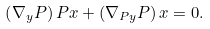Convert formula to latex. <formula><loc_0><loc_0><loc_500><loc_500>\left ( \nabla _ { y } P \right ) P x + \left ( \nabla _ { P y } P \right ) x = 0 .</formula> 